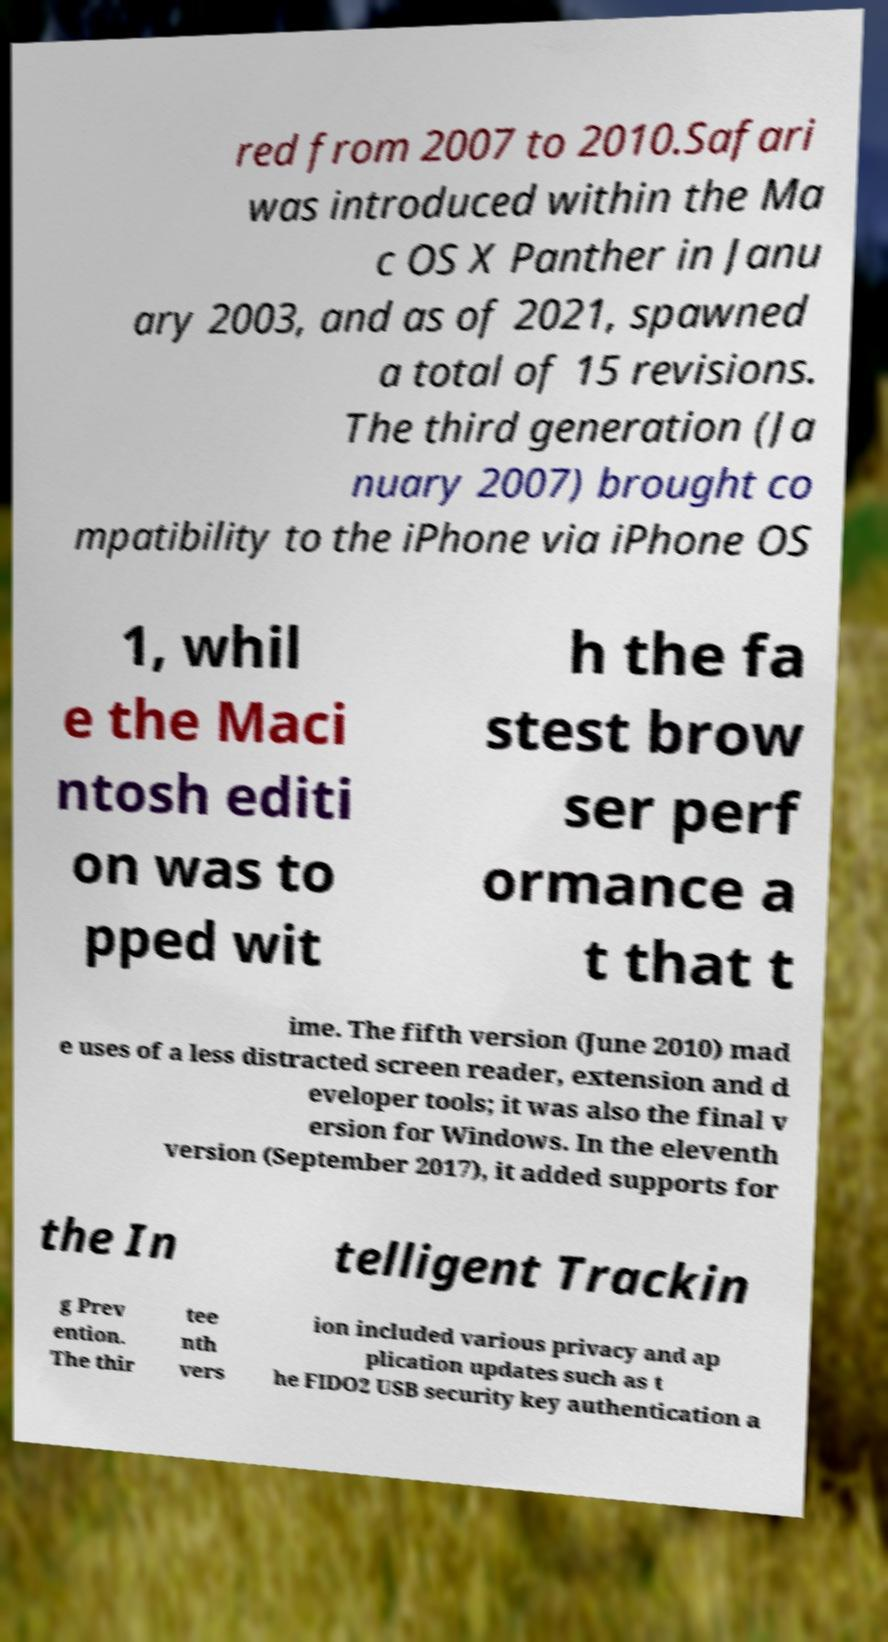There's text embedded in this image that I need extracted. Can you transcribe it verbatim? red from 2007 to 2010.Safari was introduced within the Ma c OS X Panther in Janu ary 2003, and as of 2021, spawned a total of 15 revisions. The third generation (Ja nuary 2007) brought co mpatibility to the iPhone via iPhone OS 1, whil e the Maci ntosh editi on was to pped wit h the fa stest brow ser perf ormance a t that t ime. The fifth version (June 2010) mad e uses of a less distracted screen reader, extension and d eveloper tools; it was also the final v ersion for Windows. In the eleventh version (September 2017), it added supports for the In telligent Trackin g Prev ention. The thir tee nth vers ion included various privacy and ap plication updates such as t he FIDO2 USB security key authentication a 